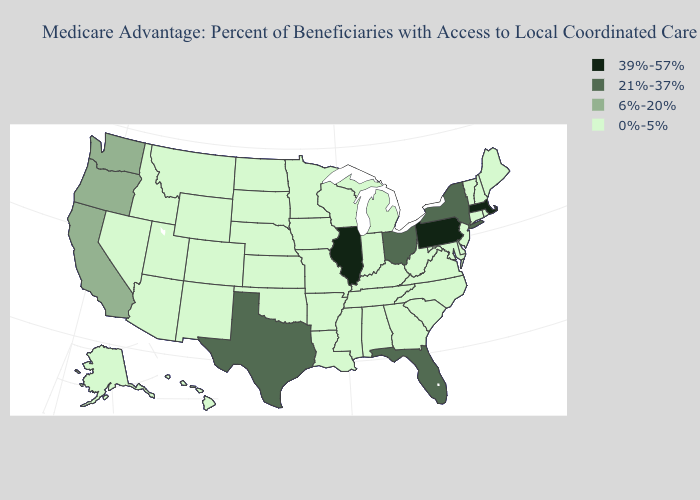What is the value of North Dakota?
Be succinct. 0%-5%. Name the states that have a value in the range 21%-37%?
Concise answer only. Florida, New York, Ohio, Texas. What is the lowest value in the Northeast?
Concise answer only. 0%-5%. What is the lowest value in the USA?
Quick response, please. 0%-5%. What is the value of New York?
Write a very short answer. 21%-37%. Name the states that have a value in the range 21%-37%?
Keep it brief. Florida, New York, Ohio, Texas. Name the states that have a value in the range 0%-5%?
Quick response, please. Alaska, Alabama, Arkansas, Arizona, Colorado, Connecticut, Delaware, Georgia, Hawaii, Iowa, Idaho, Indiana, Kansas, Kentucky, Louisiana, Maryland, Maine, Michigan, Minnesota, Missouri, Mississippi, Montana, North Carolina, North Dakota, Nebraska, New Hampshire, New Jersey, New Mexico, Nevada, Oklahoma, Rhode Island, South Carolina, South Dakota, Tennessee, Utah, Virginia, Vermont, Wisconsin, West Virginia, Wyoming. Is the legend a continuous bar?
Quick response, please. No. What is the value of Colorado?
Concise answer only. 0%-5%. Among the states that border California , which have the highest value?
Write a very short answer. Oregon. What is the highest value in states that border Arizona?
Give a very brief answer. 6%-20%. Name the states that have a value in the range 0%-5%?
Be succinct. Alaska, Alabama, Arkansas, Arizona, Colorado, Connecticut, Delaware, Georgia, Hawaii, Iowa, Idaho, Indiana, Kansas, Kentucky, Louisiana, Maryland, Maine, Michigan, Minnesota, Missouri, Mississippi, Montana, North Carolina, North Dakota, Nebraska, New Hampshire, New Jersey, New Mexico, Nevada, Oklahoma, Rhode Island, South Carolina, South Dakota, Tennessee, Utah, Virginia, Vermont, Wisconsin, West Virginia, Wyoming. Name the states that have a value in the range 6%-20%?
Quick response, please. California, Oregon, Washington. Does Indiana have the highest value in the MidWest?
Write a very short answer. No. Does Tennessee have the lowest value in the South?
Answer briefly. Yes. 